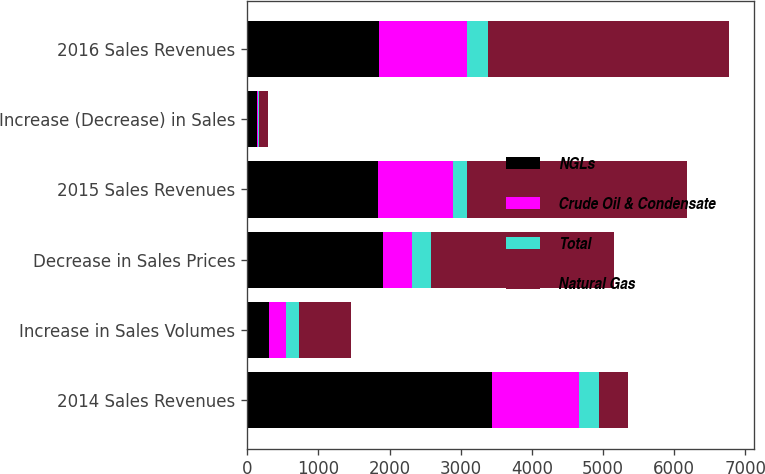Convert chart. <chart><loc_0><loc_0><loc_500><loc_500><stacked_bar_chart><ecel><fcel>2014 Sales Revenues<fcel>Increase in Sales Volumes<fcel>Decrease in Sales Prices<fcel>2015 Sales Revenues<fcel>Increase (Decrease) in Sales<fcel>2016 Sales Revenues<nl><fcel>NGLs<fcel>3438<fcel>306<fcel>1904<fcel>1840<fcel>139<fcel>1854<nl><fcel>Crude Oil & Condensate<fcel>1223<fcel>241<fcel>408<fcel>1056<fcel>7<fcel>1239<nl><fcel>Total<fcel>284<fcel>181<fcel>268<fcel>197<fcel>15<fcel>296<nl><fcel>Natural Gas<fcel>408<fcel>728<fcel>2580<fcel>3093<fcel>131<fcel>3389<nl></chart> 